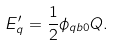Convert formula to latex. <formula><loc_0><loc_0><loc_500><loc_500>E ^ { \prime } _ { q } = \frac { 1 } { 2 } \phi _ { q b 0 } Q .</formula> 